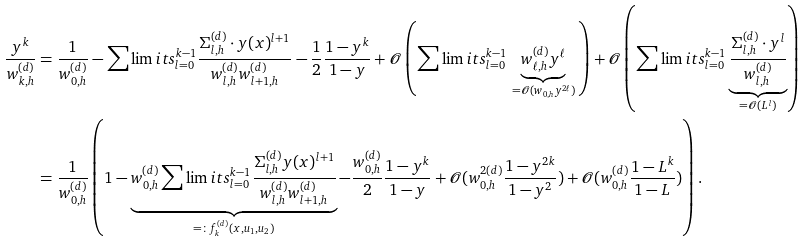Convert formula to latex. <formula><loc_0><loc_0><loc_500><loc_500>\frac { y ^ { k } } { w _ { k , h } ^ { ( d ) } } & = \frac { 1 } { w _ { 0 , h } ^ { ( d ) } } - \sum \lim i t s _ { l = 0 } ^ { k - 1 } \frac { \Sigma _ { l , h } ^ { ( d ) } \cdot y ( x ) ^ { l + 1 } } { w _ { l , h } ^ { ( d ) } w _ { l + 1 , h } ^ { ( d ) } } - \frac { 1 } { 2 } \frac { 1 - y ^ { k } } { 1 - y } + \mathcal { O } \left ( \sum \lim i t s _ { l = 0 } ^ { k - 1 } \, \underbrace { w _ { \ell , h } ^ { ( d ) } y ^ { \ell } } _ { = \mathcal { O } ( w _ { 0 , h } y ^ { 2 \ell } ) } \, \right ) + \mathcal { O } \left ( \sum \lim i t s _ { l = 0 } ^ { k - 1 } \underbrace { \frac { \Sigma _ { l , h } ^ { ( d ) } \cdot y ^ { l } } { w _ { l , h } ^ { ( d ) } } } _ { = \mathcal { O } ( L ^ { l } ) } \right ) \\ & = \frac { 1 } { w _ { 0 , h } ^ { ( d ) } } \left ( 1 - \underbrace { w _ { 0 , h } ^ { ( d ) } \sum \lim i t s _ { l = 0 } ^ { k - 1 } \frac { \Sigma _ { l , h } ^ { ( d ) } y ( x ) ^ { l + 1 } } { w _ { l , h } ^ { ( d ) } w _ { l + 1 , h } ^ { ( d ) } } } _ { = \colon f _ { k } ^ { ( d ) } ( x , u _ { 1 } , u _ { 2 } ) } - \frac { w _ { 0 , h } ^ { ( d ) } } { 2 } \frac { 1 - y ^ { k } } { 1 - y } + \mathcal { O } ( w _ { 0 , h } ^ { 2 ( d ) } \frac { 1 - y ^ { 2 k } } { 1 - y ^ { 2 } } ) + \mathcal { O } ( w _ { 0 , h } ^ { ( d ) } \frac { 1 - L ^ { k } } { 1 - L } ) \right ) .</formula> 